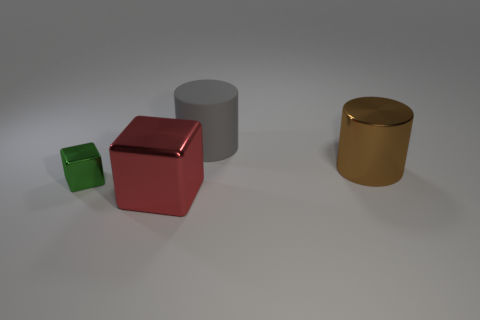Add 2 brown metal cylinders. How many objects exist? 6 Subtract all brown cylinders. Subtract all red shiny things. How many objects are left? 2 Add 4 small cubes. How many small cubes are left? 5 Add 4 gray matte cylinders. How many gray matte cylinders exist? 5 Subtract 1 brown cylinders. How many objects are left? 3 